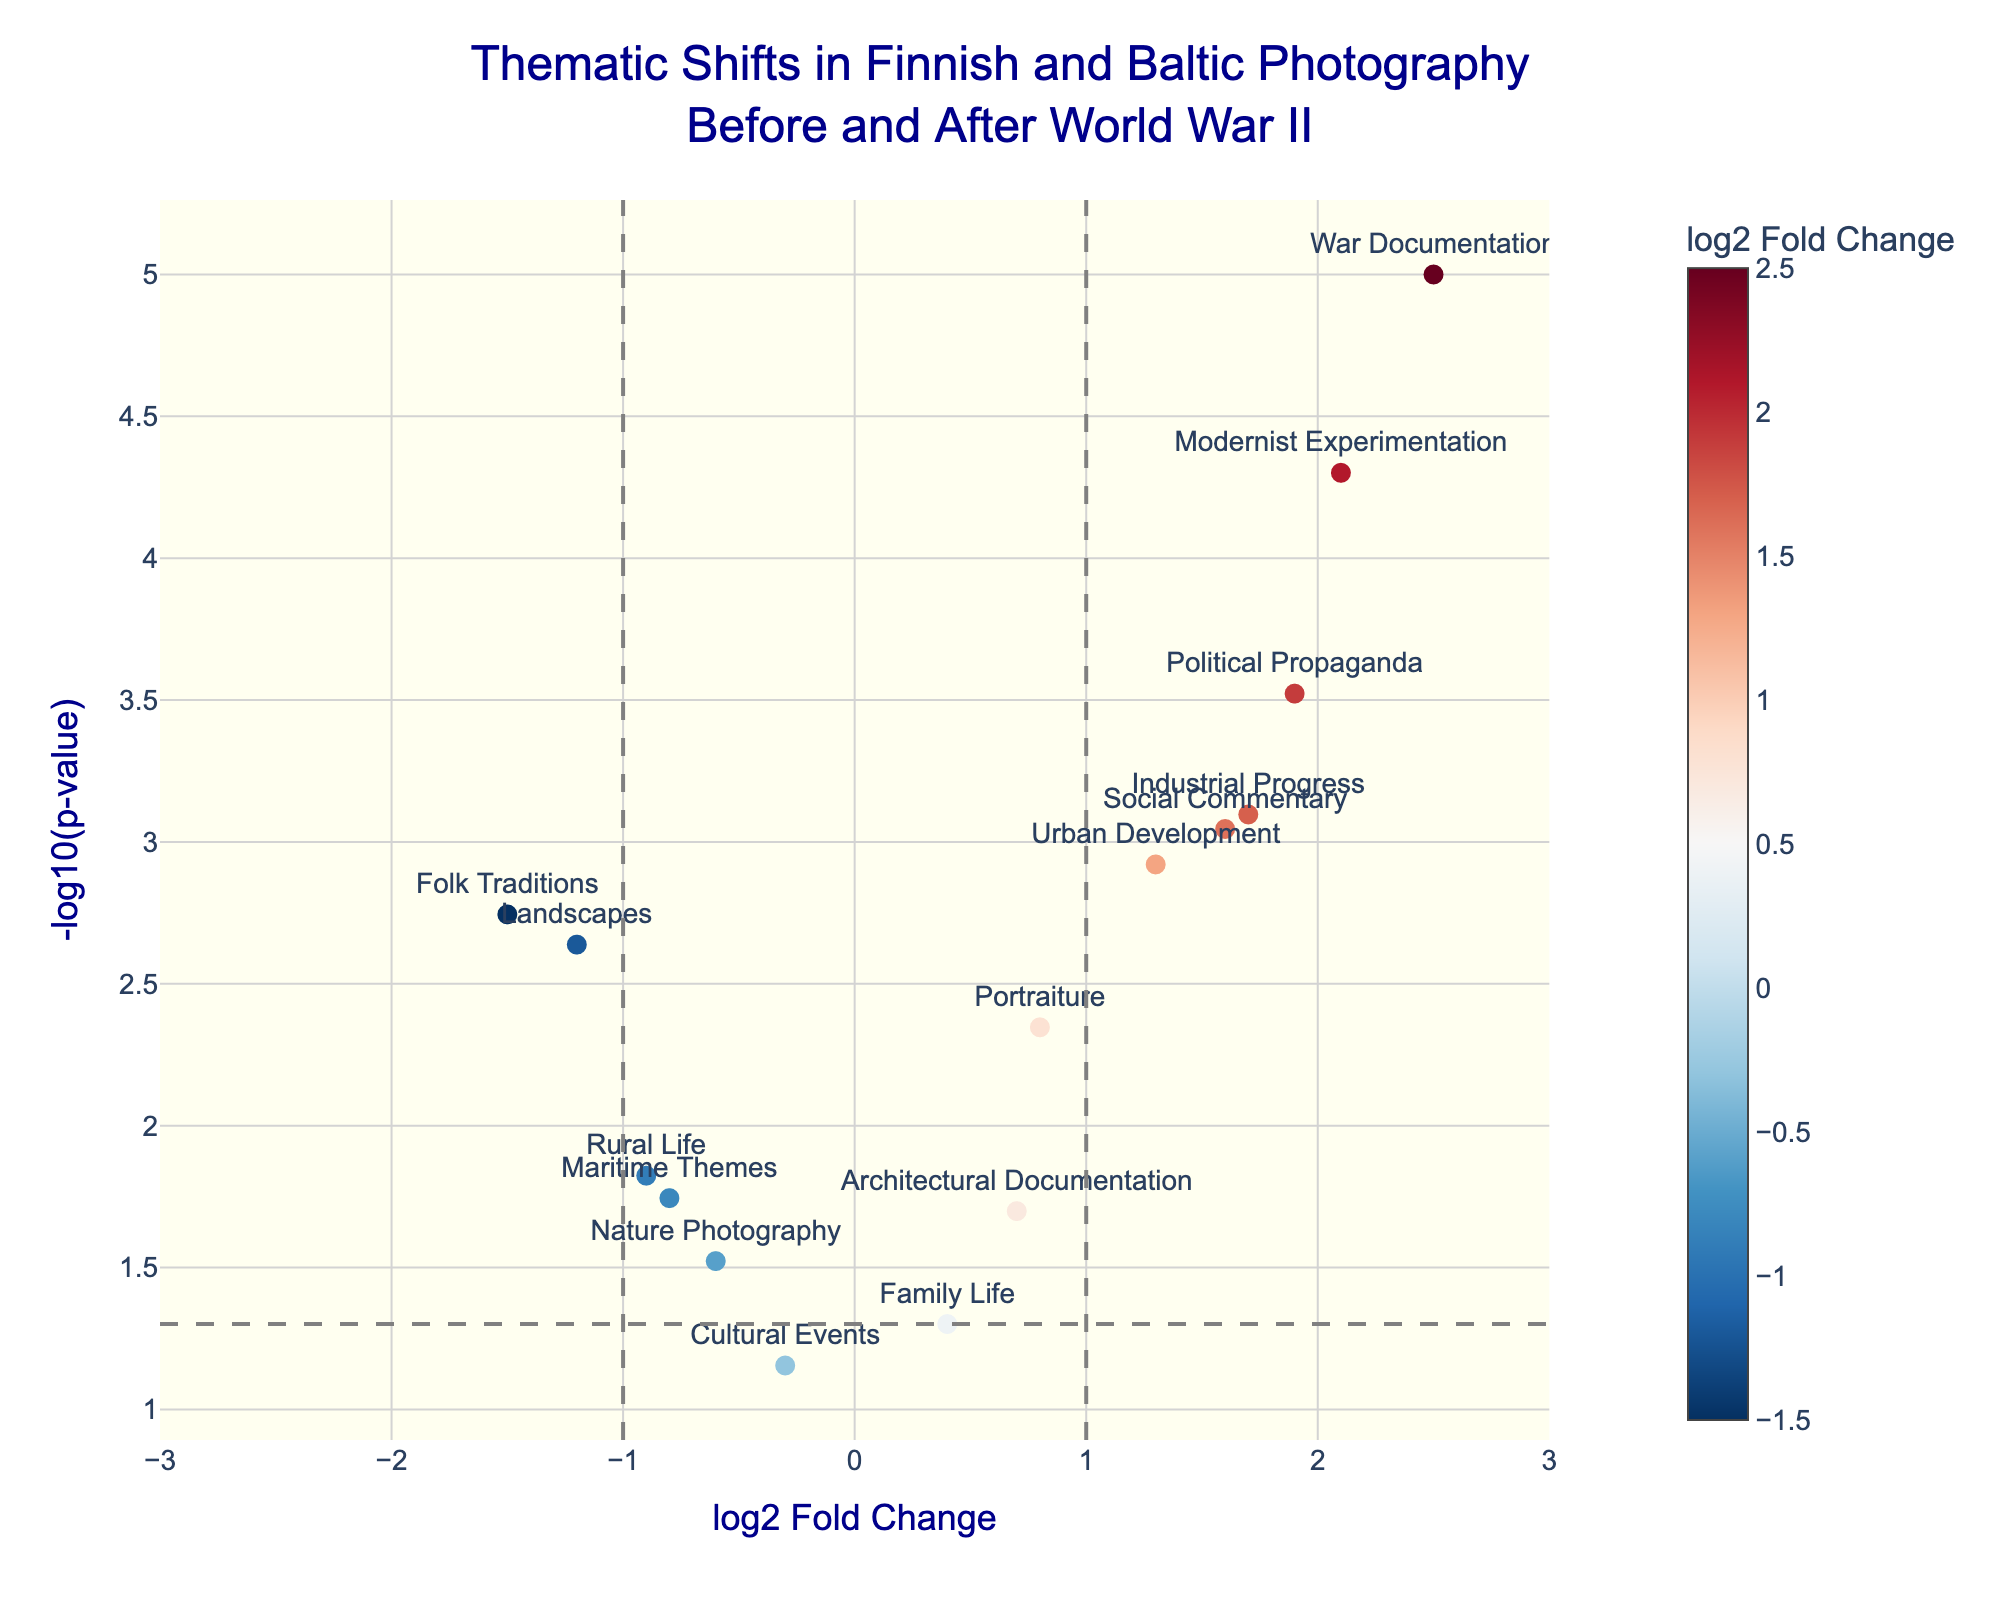What's the theme that shows the highest log2 Fold Change? Looking at the figure, the theme farthest to the right on the x-axis represents the highest log2 Fold Change, which is "War Documentation" at 2.5.
Answer: War Documentation How many themes have a p-value less than 0.05? Themes with a p-value less than 0.05 are represented above the horizontal dashed line in the plot. By counting these data points, there are 12 themes below the threshold.
Answer: 12 Which theme has the most negative log2 Fold Change? The theme farthest to the left on the x-axis shows the most negative log2 Fold Change. This theme is "Folk Traditions" with a log2 Fold Change of -1.5.
Answer: Folk Traditions What is the relationship between "Industrial Progress" and "Urban Development" in terms of log2 Fold Change? Both themes are on the right side of the plot, indicating positive log2 Fold Change. "Industrial Progress" has a log2 Fold Change of 1.7, while "Urban Development" has 1.3. Therefore, "Industrial Progress" has a higher log2 Fold Change.
Answer: Industrial Progress > Urban Development Which themes fall within the -1 to 1 log2 Fold Change range but have significant p-values (p<0.05)? Within the log2 Fold Change range of -1 to 1 and above the horizontal line (indicating significant p-values), the themes are: "Portraiture," "Rural Life," "Maritime Themes," "Nature Photography," "Architectural Documentation," and "Landscapes."
Answer: Portraiture, Rural Life, Maritime Themes, Nature Photography, Architectural Documentation, Landscapes What does the color scale represent in the plot? The color scale represents the log2 Fold Change of themes, where different colors indicate varying levels of fold change with red and blue hues.
Answer: log2 Fold Change Why are the vertical lines at -1 and 1 significant in the plot? The vertical dashed lines at log2 Fold Changes of -1 and 1 mark the thresholds distinguishing themes with significant biological relevance (indicating up-regulation or down-regulation) from those considered less significant.
Answer: Thresholds for significance Explain the significance of the horizontal dashed line in the plot. The horizontal dashed line at -log10(p-value) corresponding to 0.05 p-value indicates the significance threshold. Points above this line are considered significantly different in thematic content before and after World War II.
Answer: Significance threshold What can we infer about "Modernist Experimentation" from the plot? "Modernist Experimentation" has a log2 Fold Change of 2.1 and a very low p-value (above the significance threshold), indicating it saw a significant increase after World War II.
Answer: Significant increase Compare the themes "Family Life" and "Cultural Events" in terms of their p-values. Both themes are near the 0.05 p-value, indicated by being close to the horizontal line. However, "Family Life" has a p-value slightly above 0.05, while "Cultural Events" is slightly below. Thus, "Cultural Events" has a slightly more significant p-value.
Answer: Cultural Events < Family Life 